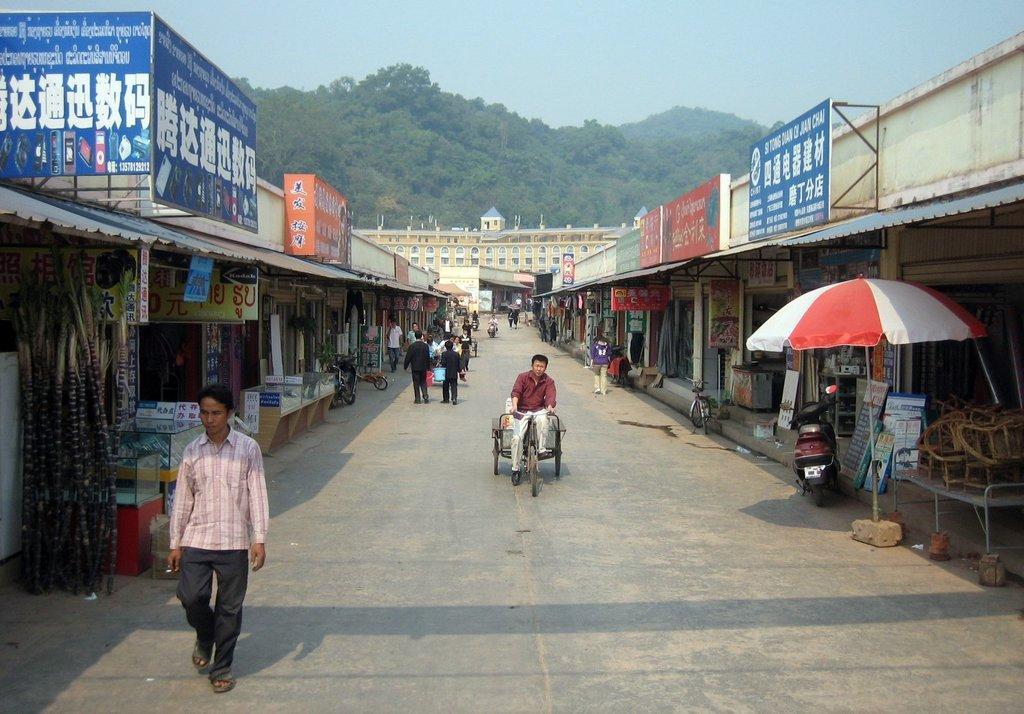Please provide a concise description of this image. In this image there are people walking on a pavement, on either side of the pavement there are shops, for that shops there are boards, on that boards there is some text, in the background there is mountain on that mountain there are trees and the sky. 